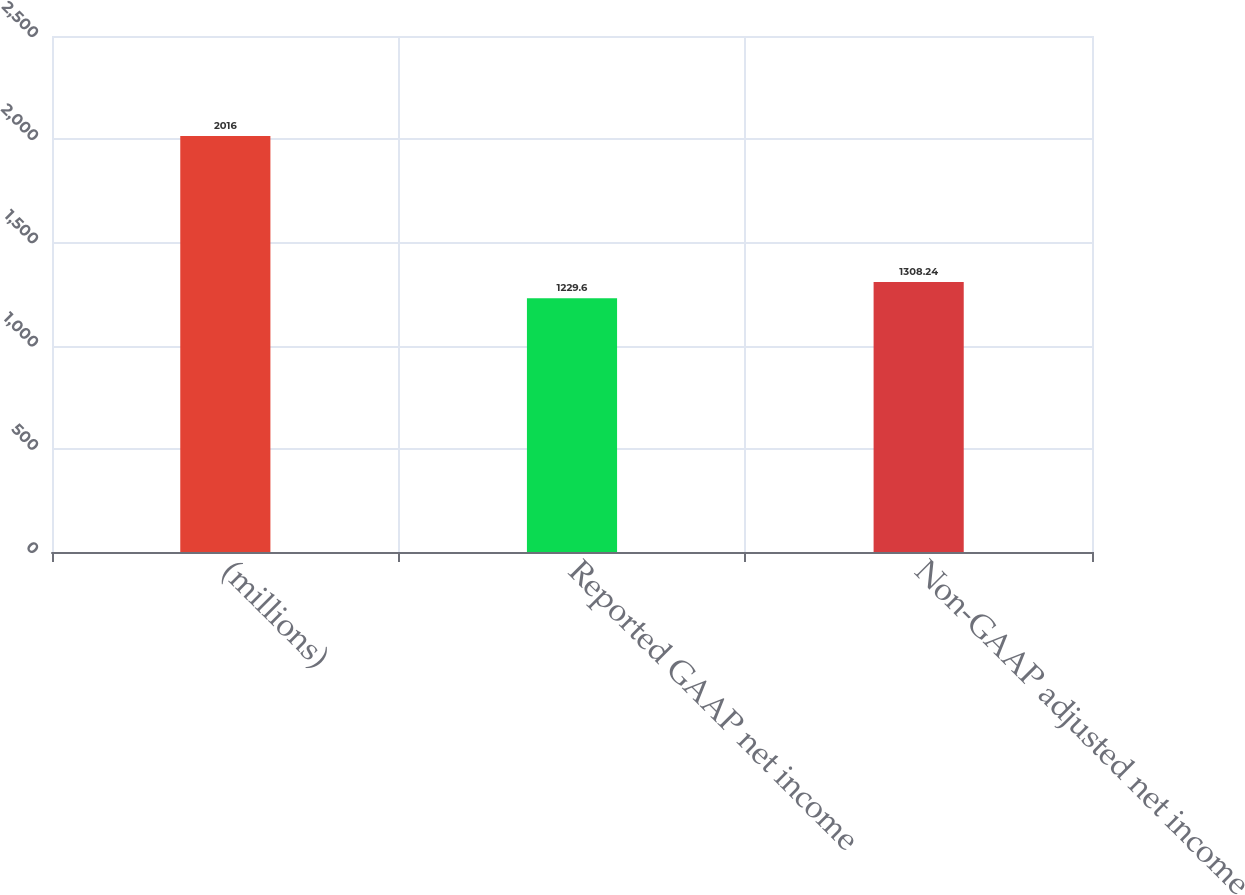<chart> <loc_0><loc_0><loc_500><loc_500><bar_chart><fcel>(millions)<fcel>Reported GAAP net income<fcel>Non-GAAP adjusted net income<nl><fcel>2016<fcel>1229.6<fcel>1308.24<nl></chart> 